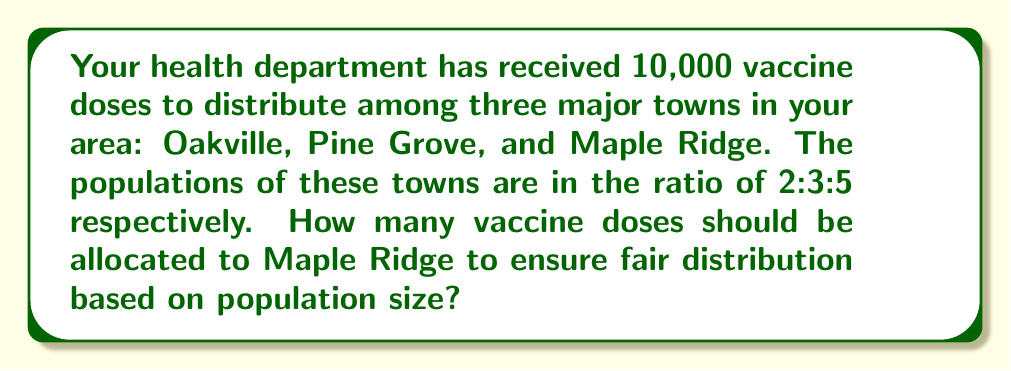What is the answer to this math problem? To solve this problem, we need to use ratios and proportions. Let's break it down step-by-step:

1) First, let's define our ratio:
   Oakville : Pine Grove : Maple Ridge = 2 : 3 : 5

2) The total parts in this ratio is:
   $2 + 3 + 5 = 10$ parts

3) We need to find out how many vaccine doses one part represents:
   $\frac{\text{Total vaccines}}{\text{Total parts}} = \frac{10,000}{10} = 1,000$ doses per part

4) Now, we can calculate the doses for Maple Ridge:
   Maple Ridge is represented by 5 parts in the ratio.
   $5 \times 1,000 = 5,000$ doses

5) We can verify our answer by calculating the doses for all towns:
   Oakville: $2 \times 1,000 = 2,000$ doses
   Pine Grove: $3 \times 1,000 = 3,000$ doses
   Maple Ridge: $5 \times 1,000 = 5,000$ doses

   Total: $2,000 + 3,000 + 5,000 = 10,000$ doses, which matches our initial amount.

Therefore, to ensure fair distribution based on population size, Maple Ridge should receive 5,000 vaccine doses.
Answer: 5,000 vaccine doses 